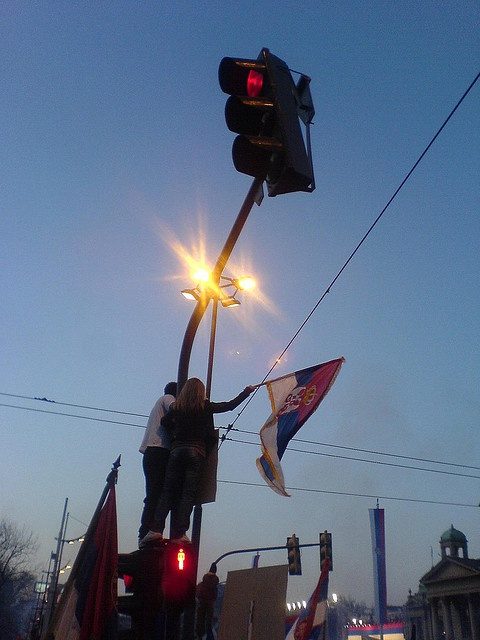Describe the objects in this image and their specific colors. I can see traffic light in gray, black, navy, and maroon tones, people in gray, black, darkgray, and maroon tones, people in gray, black, navy, and darkgray tones, traffic light in gray, maroon, black, and brown tones, and traffic light in gray and black tones in this image. 